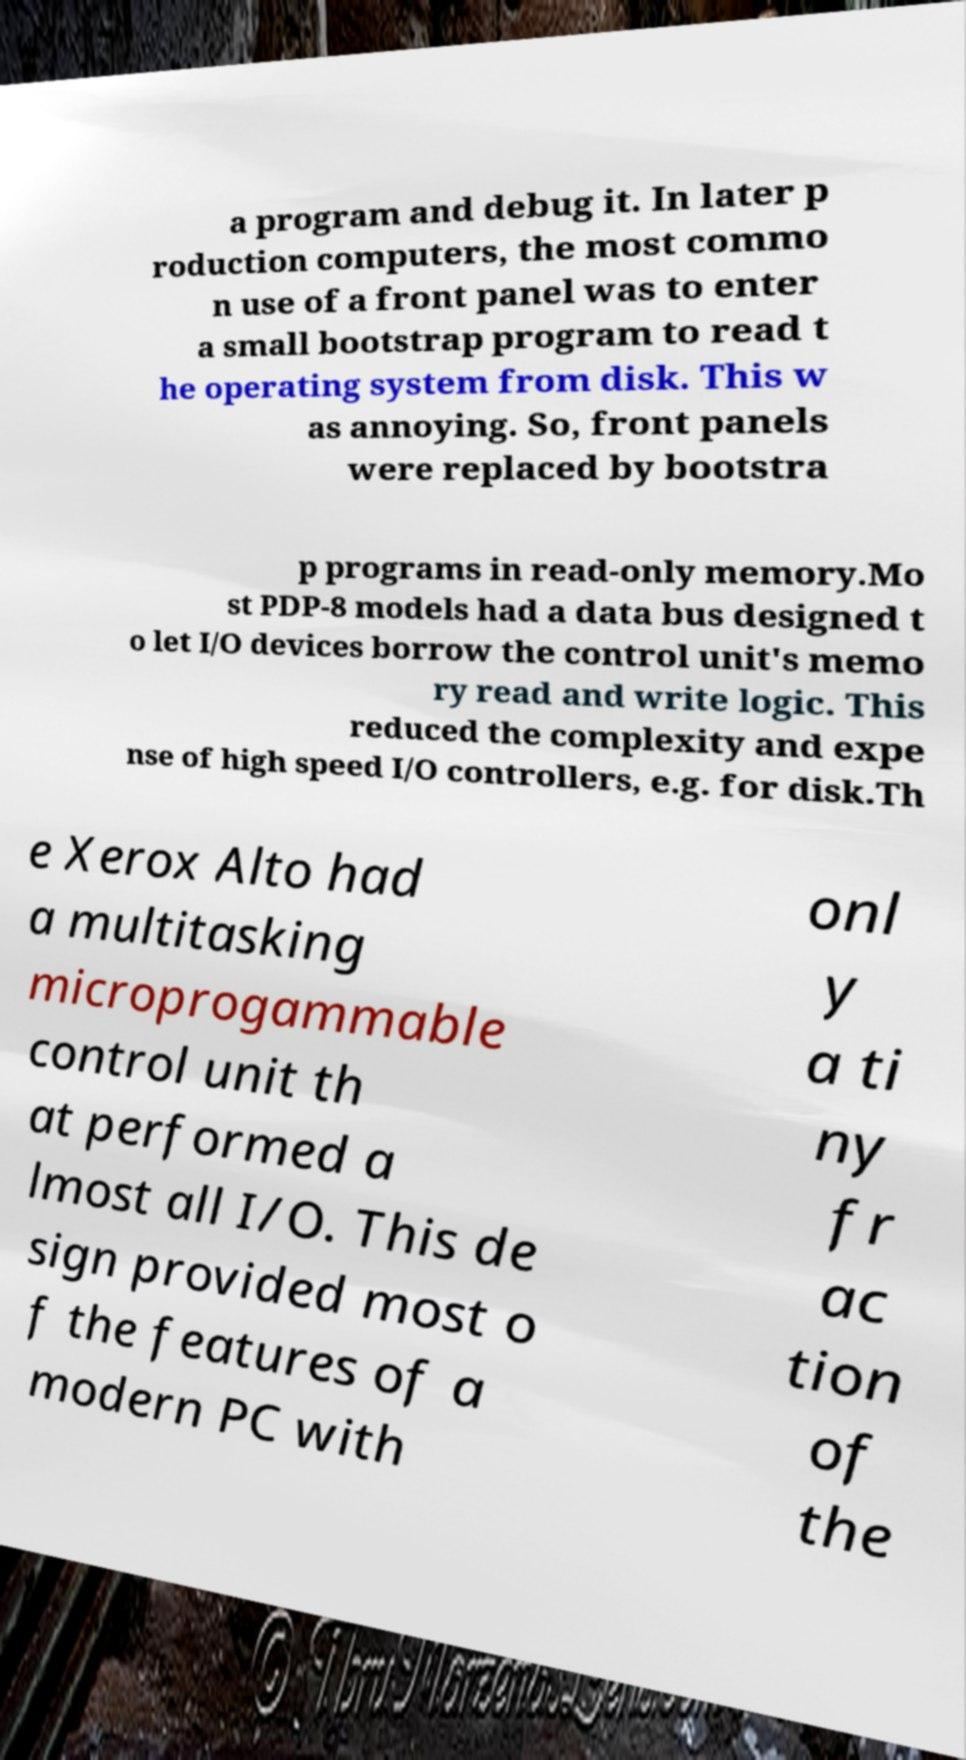Please read and relay the text visible in this image. What does it say? a program and debug it. In later p roduction computers, the most commo n use of a front panel was to enter a small bootstrap program to read t he operating system from disk. This w as annoying. So, front panels were replaced by bootstra p programs in read-only memory.Mo st PDP-8 models had a data bus designed t o let I/O devices borrow the control unit's memo ry read and write logic. This reduced the complexity and expe nse of high speed I/O controllers, e.g. for disk.Th e Xerox Alto had a multitasking microprogammable control unit th at performed a lmost all I/O. This de sign provided most o f the features of a modern PC with onl y a ti ny fr ac tion of the 